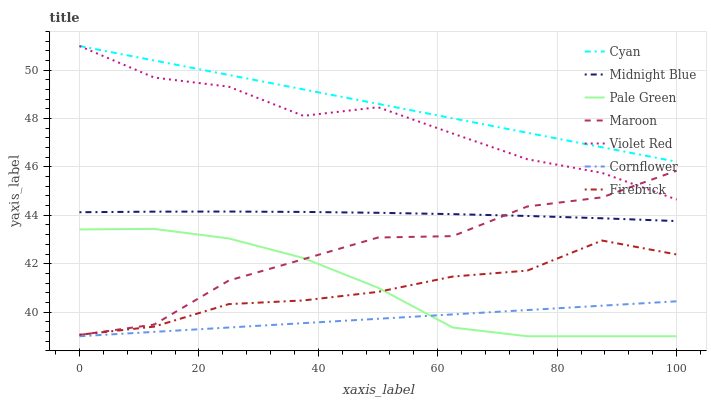Does Violet Red have the minimum area under the curve?
Answer yes or no. No. Does Violet Red have the maximum area under the curve?
Answer yes or no. No. Is Violet Red the smoothest?
Answer yes or no. No. Is Violet Red the roughest?
Answer yes or no. No. Does Violet Red have the lowest value?
Answer yes or no. No. Does Midnight Blue have the highest value?
Answer yes or no. No. Is Cornflower less than Maroon?
Answer yes or no. Yes. Is Cyan greater than Maroon?
Answer yes or no. Yes. Does Cornflower intersect Maroon?
Answer yes or no. No. 